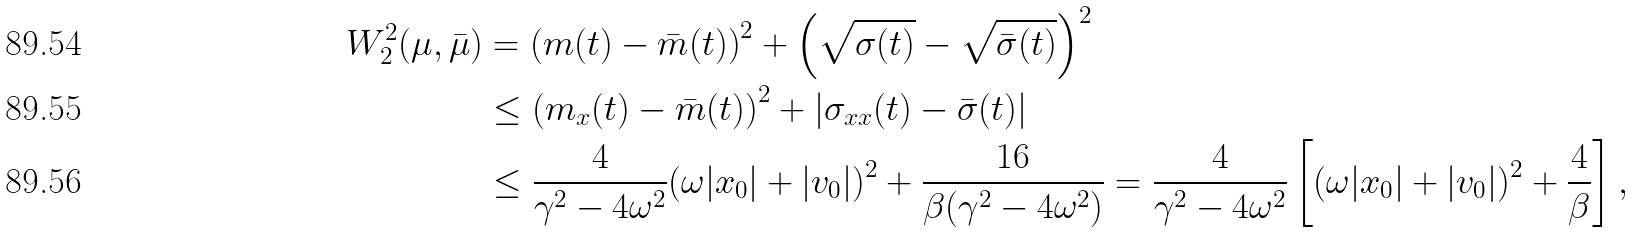<formula> <loc_0><loc_0><loc_500><loc_500>W _ { 2 } ^ { 2 } ( \mu , \bar { \mu } ) & = \left ( m ( t ) - \bar { m } ( t ) \right ) ^ { 2 } + \left ( \sqrt { \sigma ( t ) } - \sqrt { \bar { \sigma } ( t ) } \right ) ^ { 2 } \\ & \leq \left ( m _ { x } ( t ) - \bar { m } ( t ) \right ) ^ { 2 } + | \sigma _ { x x } ( t ) - \bar { \sigma } ( t ) | \\ & \leq \frac { 4 } { \gamma ^ { 2 } - 4 \omega ^ { 2 } } ( \omega | x _ { 0 } | + | v _ { 0 } | ) ^ { 2 } + \frac { 1 6 } { \beta ( \gamma ^ { 2 } - 4 \omega ^ { 2 } ) } = \frac { 4 } { \gamma ^ { 2 } - 4 \omega ^ { 2 } } \left [ ( \omega | x _ { 0 } | + | v _ { 0 } | ) ^ { 2 } + \frac { 4 } { \beta } \right ] ,</formula> 